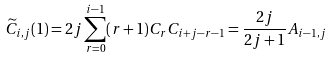<formula> <loc_0><loc_0><loc_500><loc_500>\widetilde { C } _ { i , j } ( 1 ) = 2 j \sum _ { r = 0 } ^ { i - 1 } ( r + 1 ) C _ { r } C _ { i + j - r - 1 } = \frac { 2 j } { 2 j + 1 } A _ { i - 1 , j }</formula> 